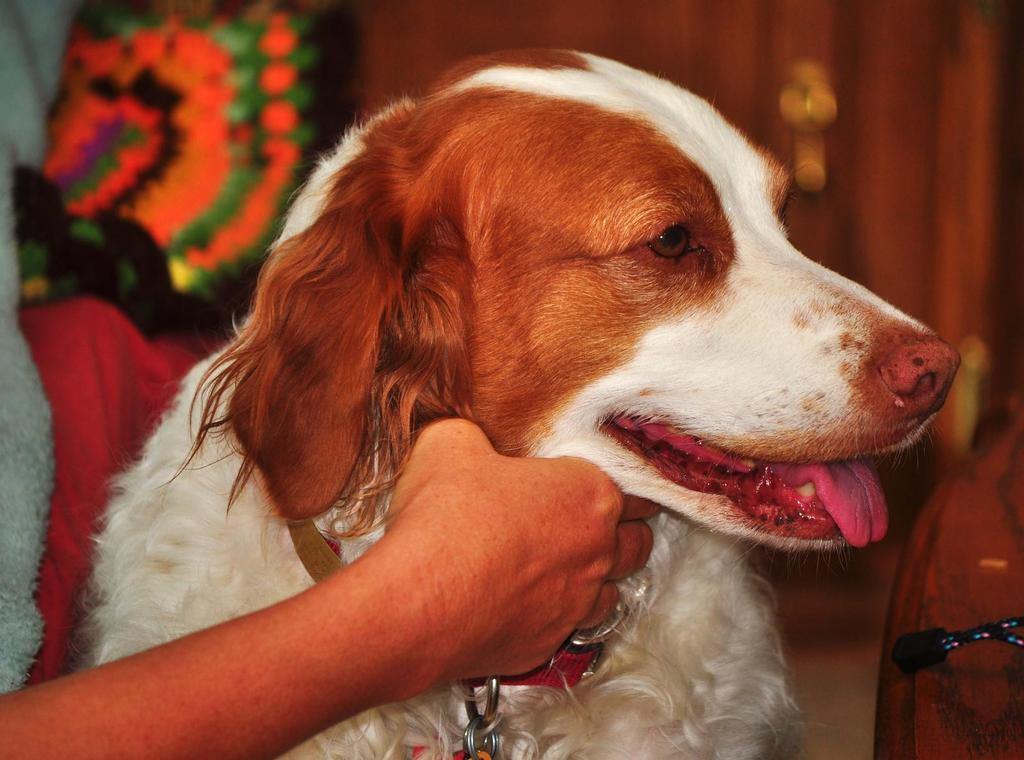What is the main subject in the center of the image? There is a dog in the center of the image. Can you describe any human interaction with the dog? A person's hand is visible in the image, suggesting some interaction with the dog. What can be said about the background of the image? The background of the image is not clear, making it difficult to provide specific details about the setting. What type of holiday is the dog celebrating in the image? There is no indication of a holiday in the image, as it primarily features a dog and a person's hand. Can you tell me which club the dog belongs to in the image? There is no club affiliation mentioned or depicted in the image; it simply shows a dog and a person's hand. 